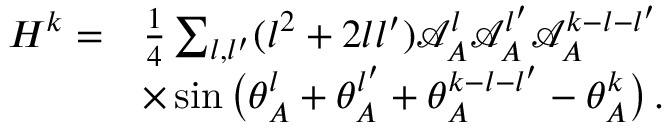<formula> <loc_0><loc_0><loc_500><loc_500>\begin{array} { r l } { H ^ { k } = } & { \frac { 1 } { 4 } \sum _ { { l } , { l ^ { \prime } } } ( { l } ^ { 2 } + 2 { l } { l ^ { \prime } } ) \mathcal { A } _ { A } ^ { l } \mathcal { A } _ { A } ^ { l ^ { \prime } } \mathcal { A } _ { A } ^ { k - { l } - { l ^ { \prime } } } } \\ & { \times \sin \left ( \theta _ { A } ^ { l } + \theta _ { A } ^ { l ^ { \prime } } + \theta _ { A } ^ { k - { l } - { l ^ { \prime } } } - \theta _ { A } ^ { k } \right ) \, . } \end{array}</formula> 